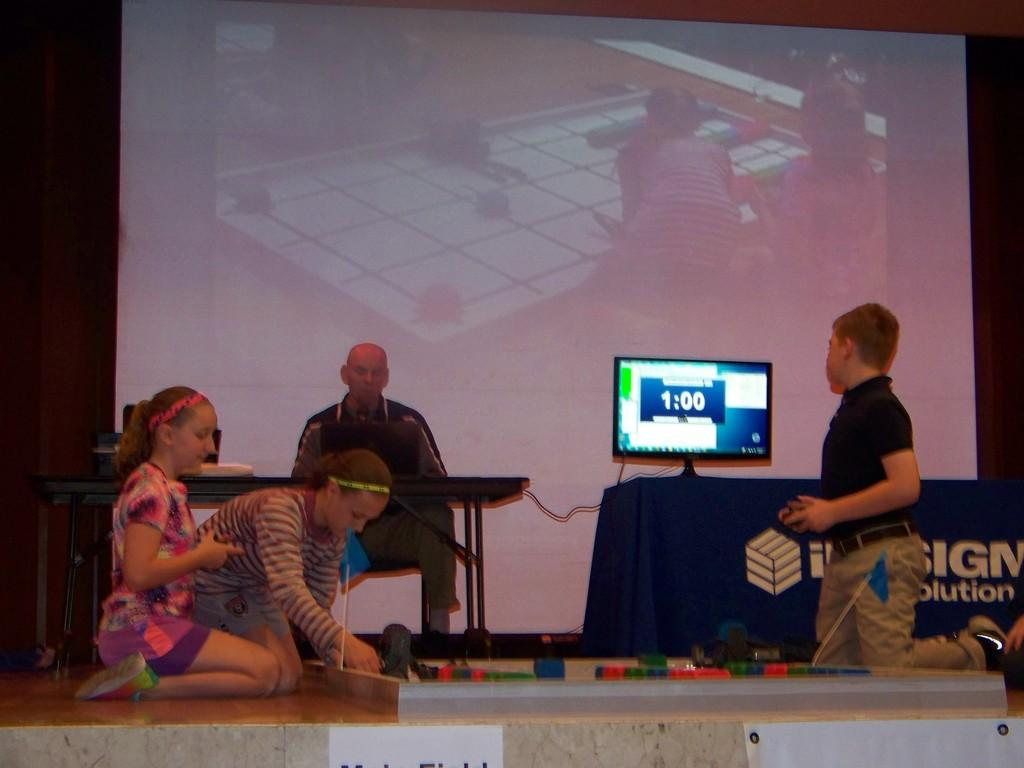<image>
Offer a succinct explanation of the picture presented. Kids on a stage playing a game with only one minute remaining. 